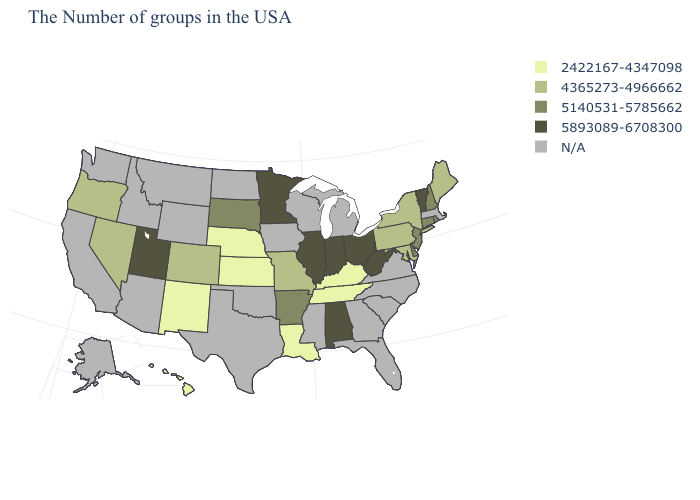Name the states that have a value in the range 5140531-5785662?
Write a very short answer. Rhode Island, New Hampshire, Connecticut, New Jersey, Delaware, Arkansas, South Dakota. Among the states that border Pennsylvania , does West Virginia have the highest value?
Quick response, please. Yes. Which states have the lowest value in the USA?
Keep it brief. Kentucky, Tennessee, Louisiana, Kansas, Nebraska, New Mexico, Hawaii. Name the states that have a value in the range 4365273-4966662?
Short answer required. Maine, New York, Maryland, Pennsylvania, Missouri, Colorado, Nevada, Oregon. What is the value of Tennessee?
Short answer required. 2422167-4347098. Does New Jersey have the highest value in the Northeast?
Be succinct. No. Does Tennessee have the highest value in the South?
Quick response, please. No. Does Delaware have the lowest value in the South?
Keep it brief. No. What is the highest value in states that border Idaho?
Write a very short answer. 5893089-6708300. What is the value of Illinois?
Answer briefly. 5893089-6708300. What is the value of Connecticut?
Write a very short answer. 5140531-5785662. What is the highest value in states that border Indiana?
Write a very short answer. 5893089-6708300. Does the first symbol in the legend represent the smallest category?
Concise answer only. Yes. Among the states that border Vermont , which have the highest value?
Keep it brief. New Hampshire. 